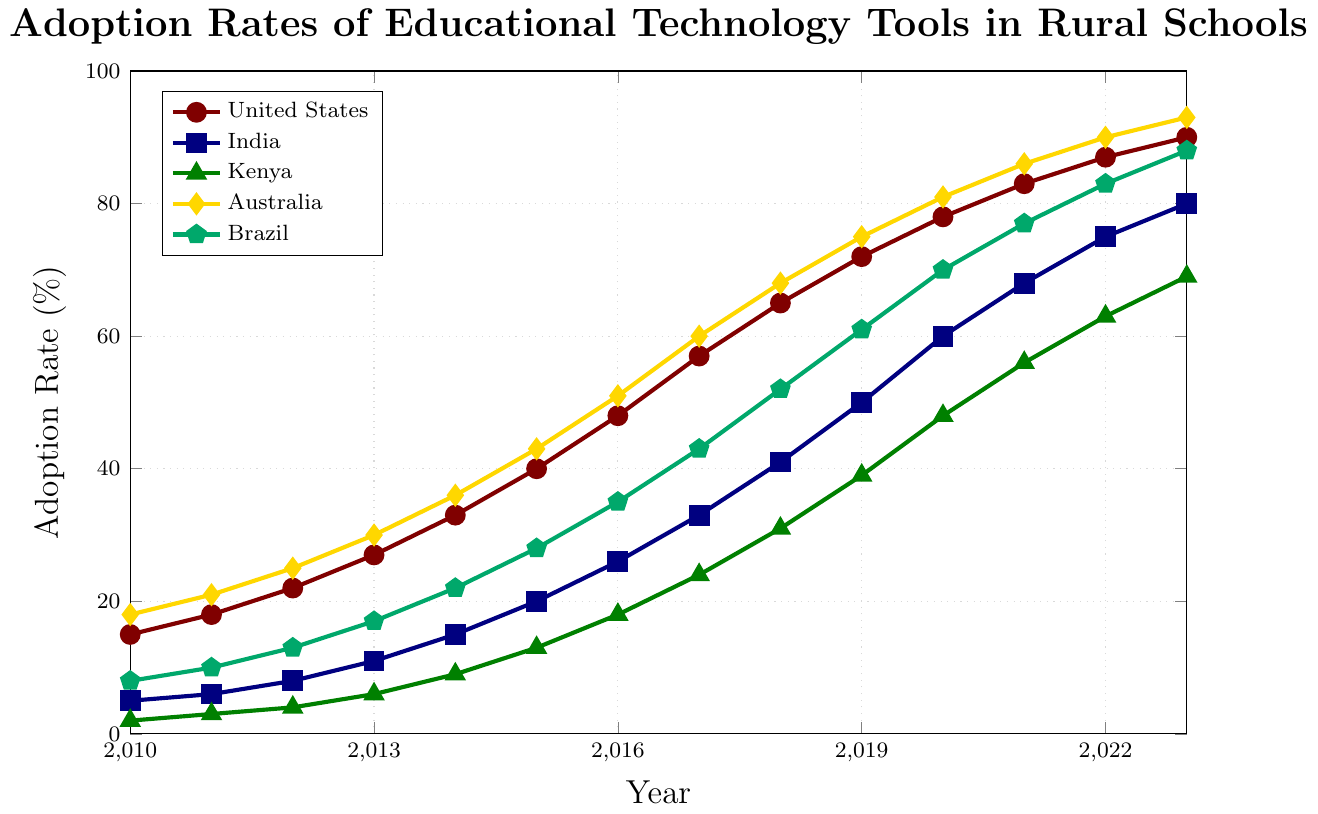What is the adoption rate of educational technology tools in rural schools in the United States in 2023? Look at the United States line (red) and find the value at 2023 on the x-axis.
Answer: 90% Which country had the highest adoption rate in 2010? Look at the y-values for each country in 2010 and identify the highest one. Australia has the highest adoption rate with 18%.
Answer: Australia How much did the adoption rate increase in Brazil from 2010 to 2023? Subtract the adoption rate for Brazil in 2010 from the adoption rate in 2023: 88 - 8 = 80.
Answer: 80% Between 2015 and 2020, which country saw the largest increase in adoption rates? Calculate the difference in adoption rates for each country between 2015 and 2020: 
- United States: 78 - 40 = 38
- India: 60 - 20 = 40
- Kenya: 48 - 13 = 35
- Australia: 81 - 43 = 38
- Brazil: 70 - 28 = 42
Brazil has the largest increase with 42%.
Answer: Brazil By how much did the adoption rate in India change from 2012 to 2015? Subtract the adoption rate for India in 2012 from the rate in 2015: 20 - 8 = 12.
Answer: 12% In which year did Kenya's adoption rate first reach above 60%? Look at the Kenya line (green) and find the first y-value above 60%. This occurs in 2021 with an adoption rate of 63%.
Answer: 2021 What is the average adoption rate for Australia from 2010 to 2023? Sum the adoption rates for Australia from 2010 to 2023 (18 + 21 + 25 + 30 + 36 + 43 + 51 + 60 + 68 + 75 + 81 + 86 + 90 + 93) and divide by the number of years (14). Total sum: 777; Average is 777/14 = 55.5.
Answer: 55.5 Compare the adoption rates in 2019 for the United States and Kenya. Which country had a higher rate and by how much? Look at the adoption rates in 2019 for both countries: United States (72), Kenya (39). Subtract Kenya's rate from the United States': 72 - 39 = 33.
Answer: United States by 33 What is the median adoption rate for India from 2010 to 2023? List the adoption rates for India (5, 6, 8, 11, 15, 20, 26, 33, 41, 50, 60, 68, 75, 80) and find the middle value. With 14 data points, the median is the average of the 7th and 8th values: (26 + 33) / 2 = 29.5.
Answer: 29.5 